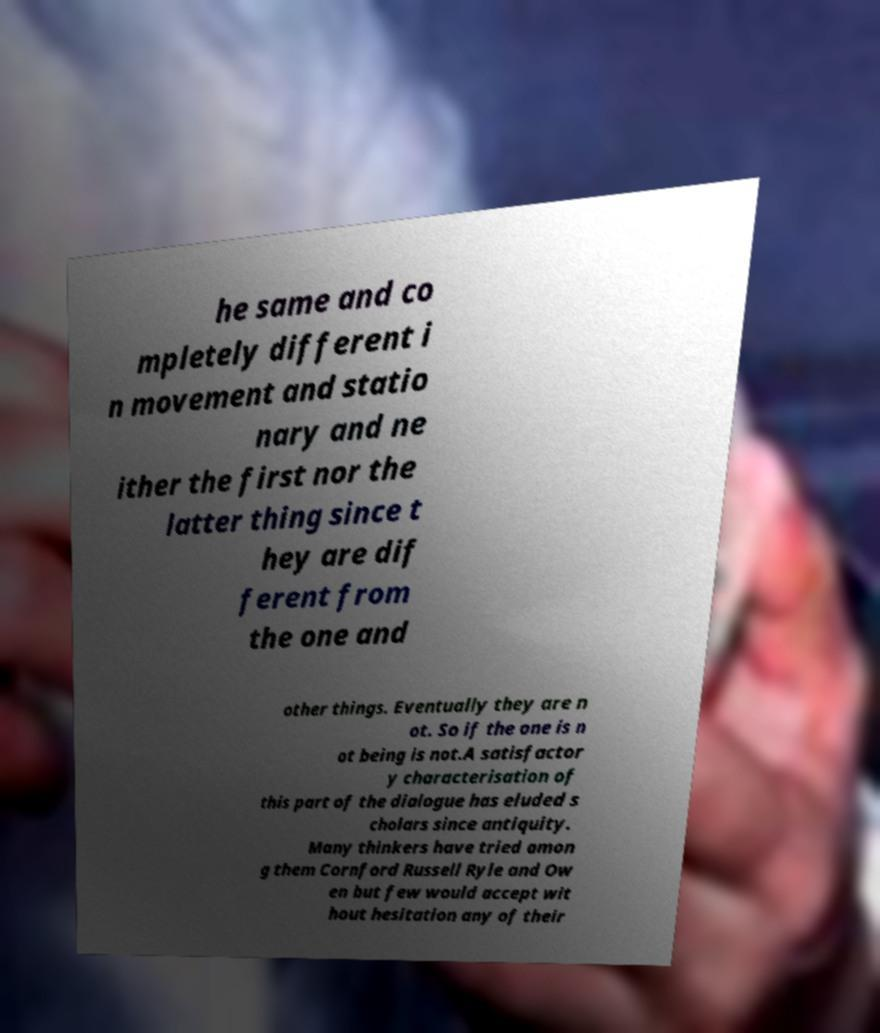Can you read and provide the text displayed in the image?This photo seems to have some interesting text. Can you extract and type it out for me? he same and co mpletely different i n movement and statio nary and ne ither the first nor the latter thing since t hey are dif ferent from the one and other things. Eventually they are n ot. So if the one is n ot being is not.A satisfactor y characterisation of this part of the dialogue has eluded s cholars since antiquity. Many thinkers have tried amon g them Cornford Russell Ryle and Ow en but few would accept wit hout hesitation any of their 